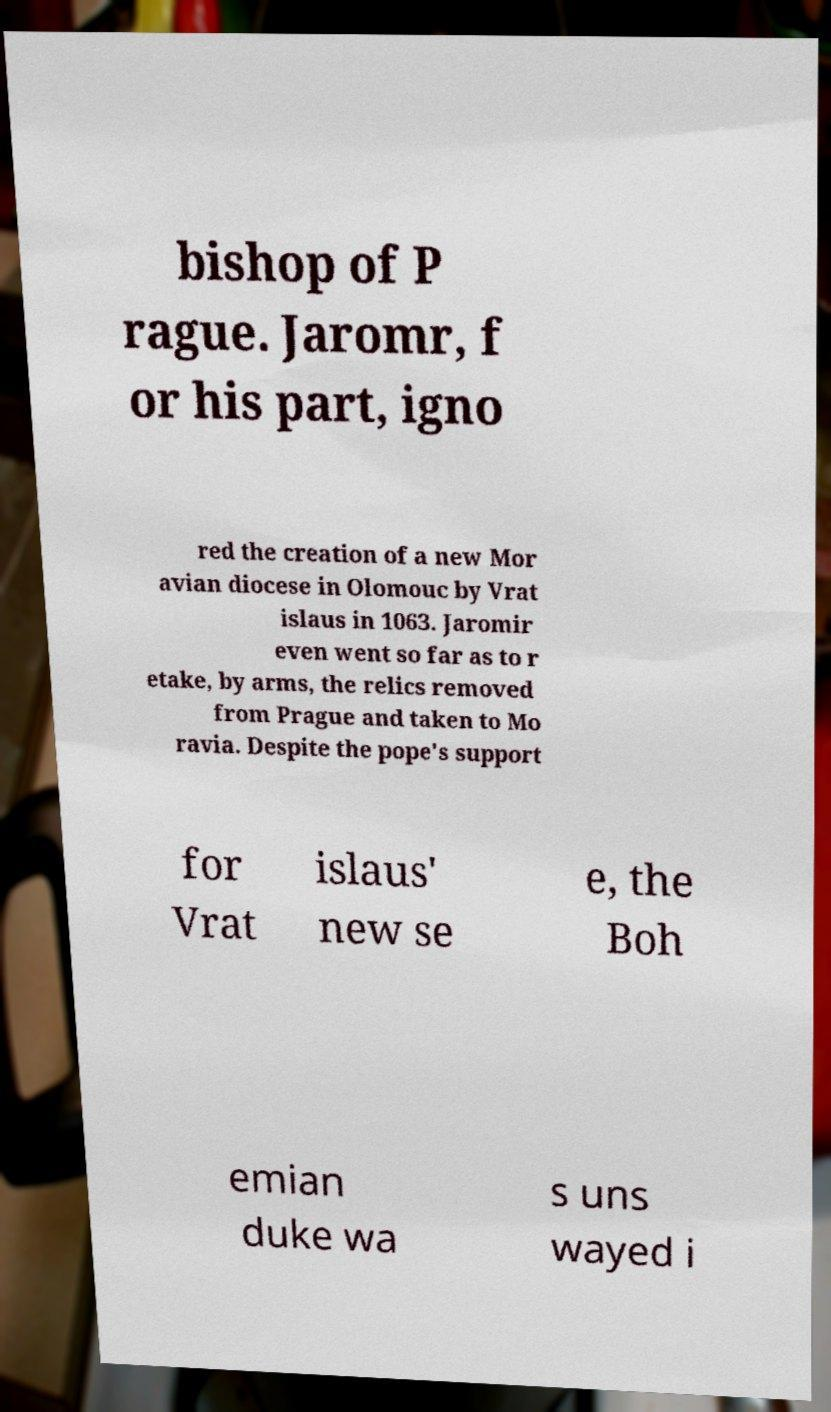Can you read and provide the text displayed in the image?This photo seems to have some interesting text. Can you extract and type it out for me? bishop of P rague. Jaromr, f or his part, igno red the creation of a new Mor avian diocese in Olomouc by Vrat islaus in 1063. Jaromir even went so far as to r etake, by arms, the relics removed from Prague and taken to Mo ravia. Despite the pope's support for Vrat islaus' new se e, the Boh emian duke wa s uns wayed i 